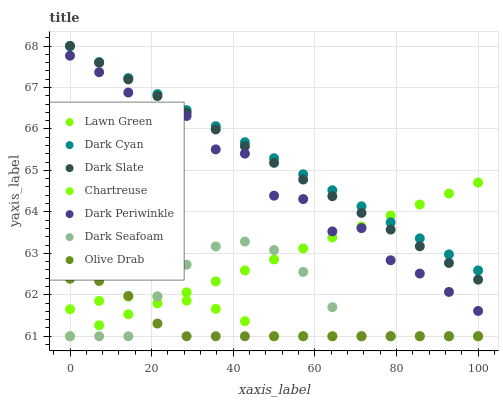Does Olive Drab have the minimum area under the curve?
Answer yes or no. Yes. Does Dark Cyan have the maximum area under the curve?
Answer yes or no. Yes. Does Dark Seafoam have the minimum area under the curve?
Answer yes or no. No. Does Dark Seafoam have the maximum area under the curve?
Answer yes or no. No. Is Dark Cyan the smoothest?
Answer yes or no. Yes. Is Dark Periwinkle the roughest?
Answer yes or no. Yes. Is Dark Seafoam the smoothest?
Answer yes or no. No. Is Dark Seafoam the roughest?
Answer yes or no. No. Does Lawn Green have the lowest value?
Answer yes or no. Yes. Does Dark Slate have the lowest value?
Answer yes or no. No. Does Dark Cyan have the highest value?
Answer yes or no. Yes. Does Dark Seafoam have the highest value?
Answer yes or no. No. Is Dark Periwinkle less than Dark Slate?
Answer yes or no. Yes. Is Dark Cyan greater than Dark Seafoam?
Answer yes or no. Yes. Does Lawn Green intersect Dark Slate?
Answer yes or no. Yes. Is Lawn Green less than Dark Slate?
Answer yes or no. No. Is Lawn Green greater than Dark Slate?
Answer yes or no. No. Does Dark Periwinkle intersect Dark Slate?
Answer yes or no. No. 